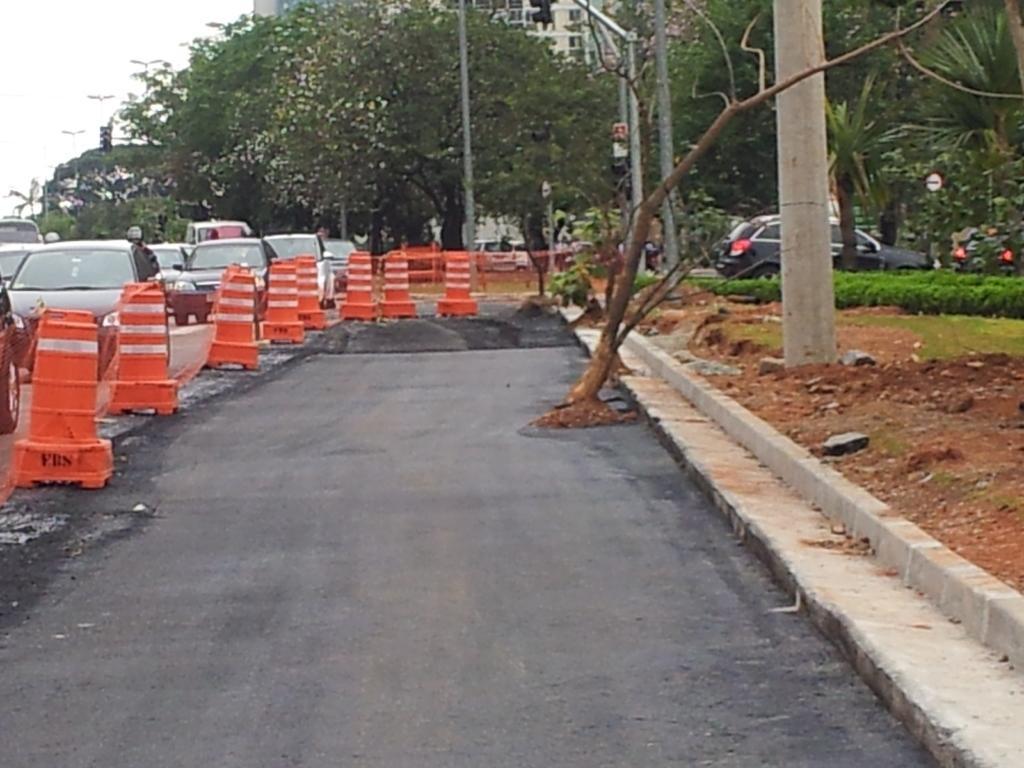Can you describe this image briefly? In this image we can see the barricades and vehicles on the road. And we can see there are poles, plants, trees and traffic lights. In the background, we can see the sky. 